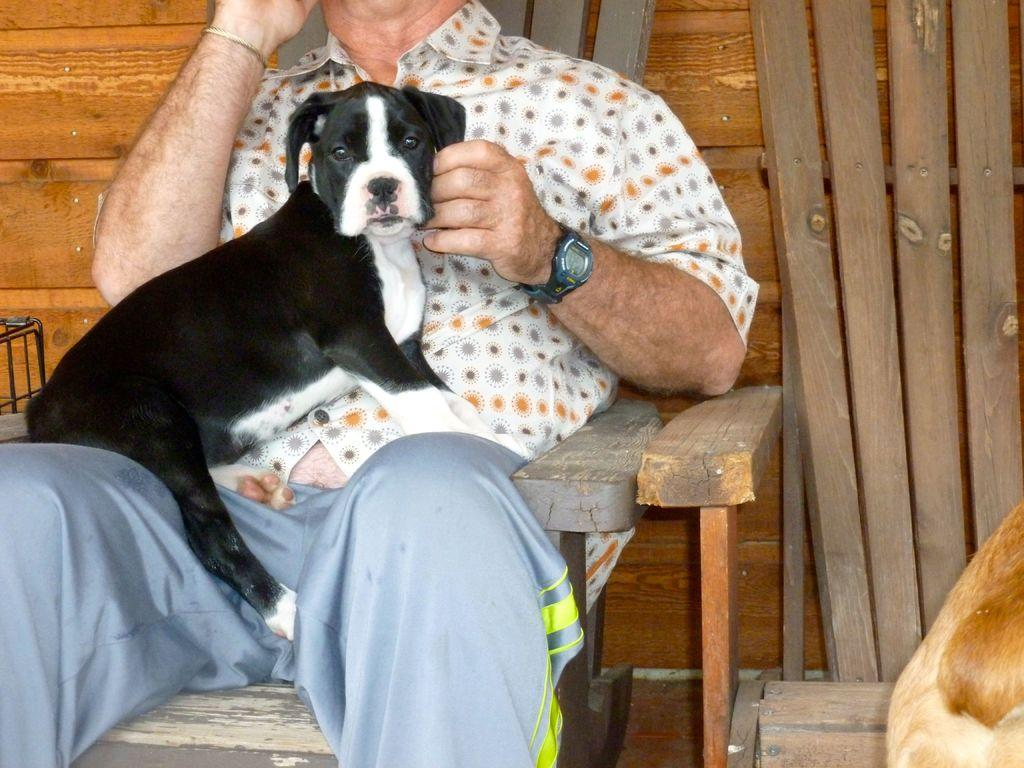What is the person in the image doing? The person is sitting on a chair in the image. What is the person holding in the image? The person is holding a dog in the image. Can you describe the chair on the right side of the image? There is another chair at the right side of the image. What type of shoes is the dog wearing in the image? There are no shoes visible on the dog in the image, as dogs do not wear shoes. 